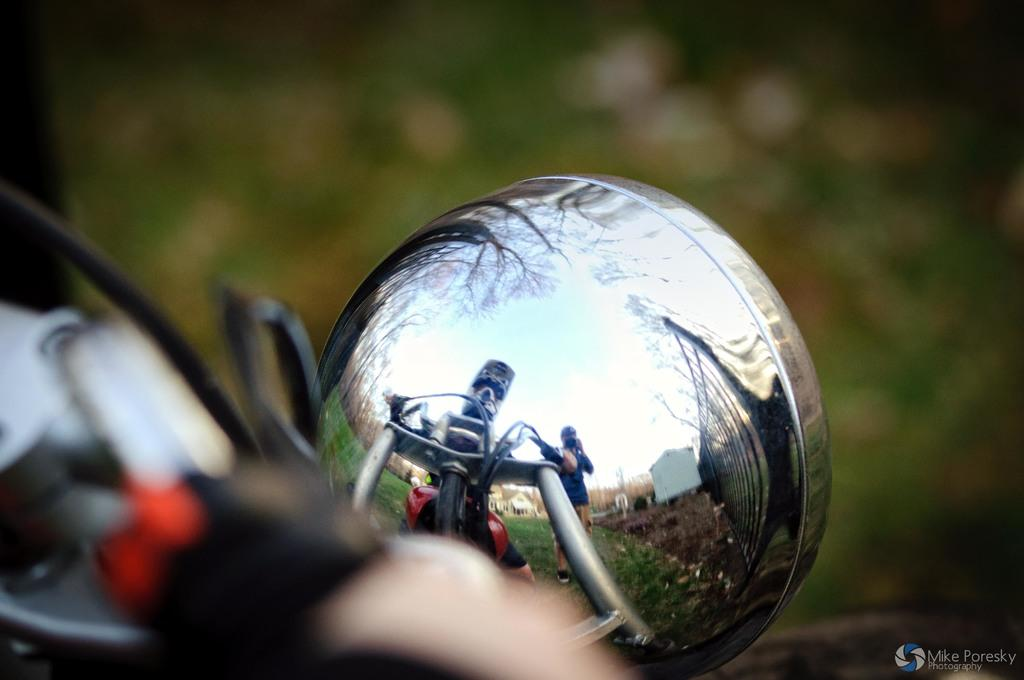What is the main subject of the image? The main subject of the image is the headlight of a vehicle. Can you describe the headlight in more detail? The headlight appears to be bright and illuminated, possibly indicating that the vehicle is turned on or in use. What type of stove is visible in the image? There is no stove present in the image; it features the headlight of a vehicle. How does the force of gravity affect the headlight in the image? The force of gravity does not affect the headlight in the image, as it is a stationary object attached to a vehicle. 